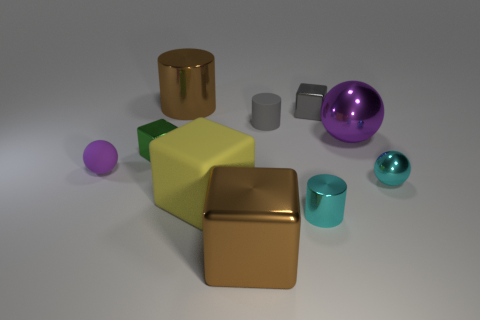Subtract all cyan shiny cylinders. How many cylinders are left? 2 Subtract all brown cylinders. How many purple balls are left? 2 Subtract all brown cylinders. How many cylinders are left? 2 Subtract all cylinders. How many objects are left? 7 Subtract all yellow spheres. Subtract all cyan cubes. How many spheres are left? 3 Subtract all large yellow matte cubes. Subtract all big brown metal objects. How many objects are left? 7 Add 9 gray cylinders. How many gray cylinders are left? 10 Add 9 large gray metallic cylinders. How many large gray metallic cylinders exist? 9 Subtract 1 yellow blocks. How many objects are left? 9 